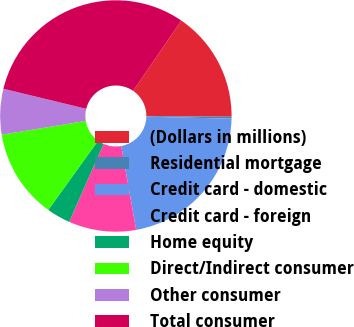<chart> <loc_0><loc_0><loc_500><loc_500><pie_chart><fcel>(Dollars in millions)<fcel>Residential mortgage<fcel>Credit card - domestic<fcel>Credit card - foreign<fcel>Home equity<fcel>Direct/Indirect consumer<fcel>Other consumer<fcel>Total consumer<nl><fcel>15.53%<fcel>0.27%<fcel>21.82%<fcel>9.42%<fcel>3.32%<fcel>12.48%<fcel>6.37%<fcel>30.79%<nl></chart> 